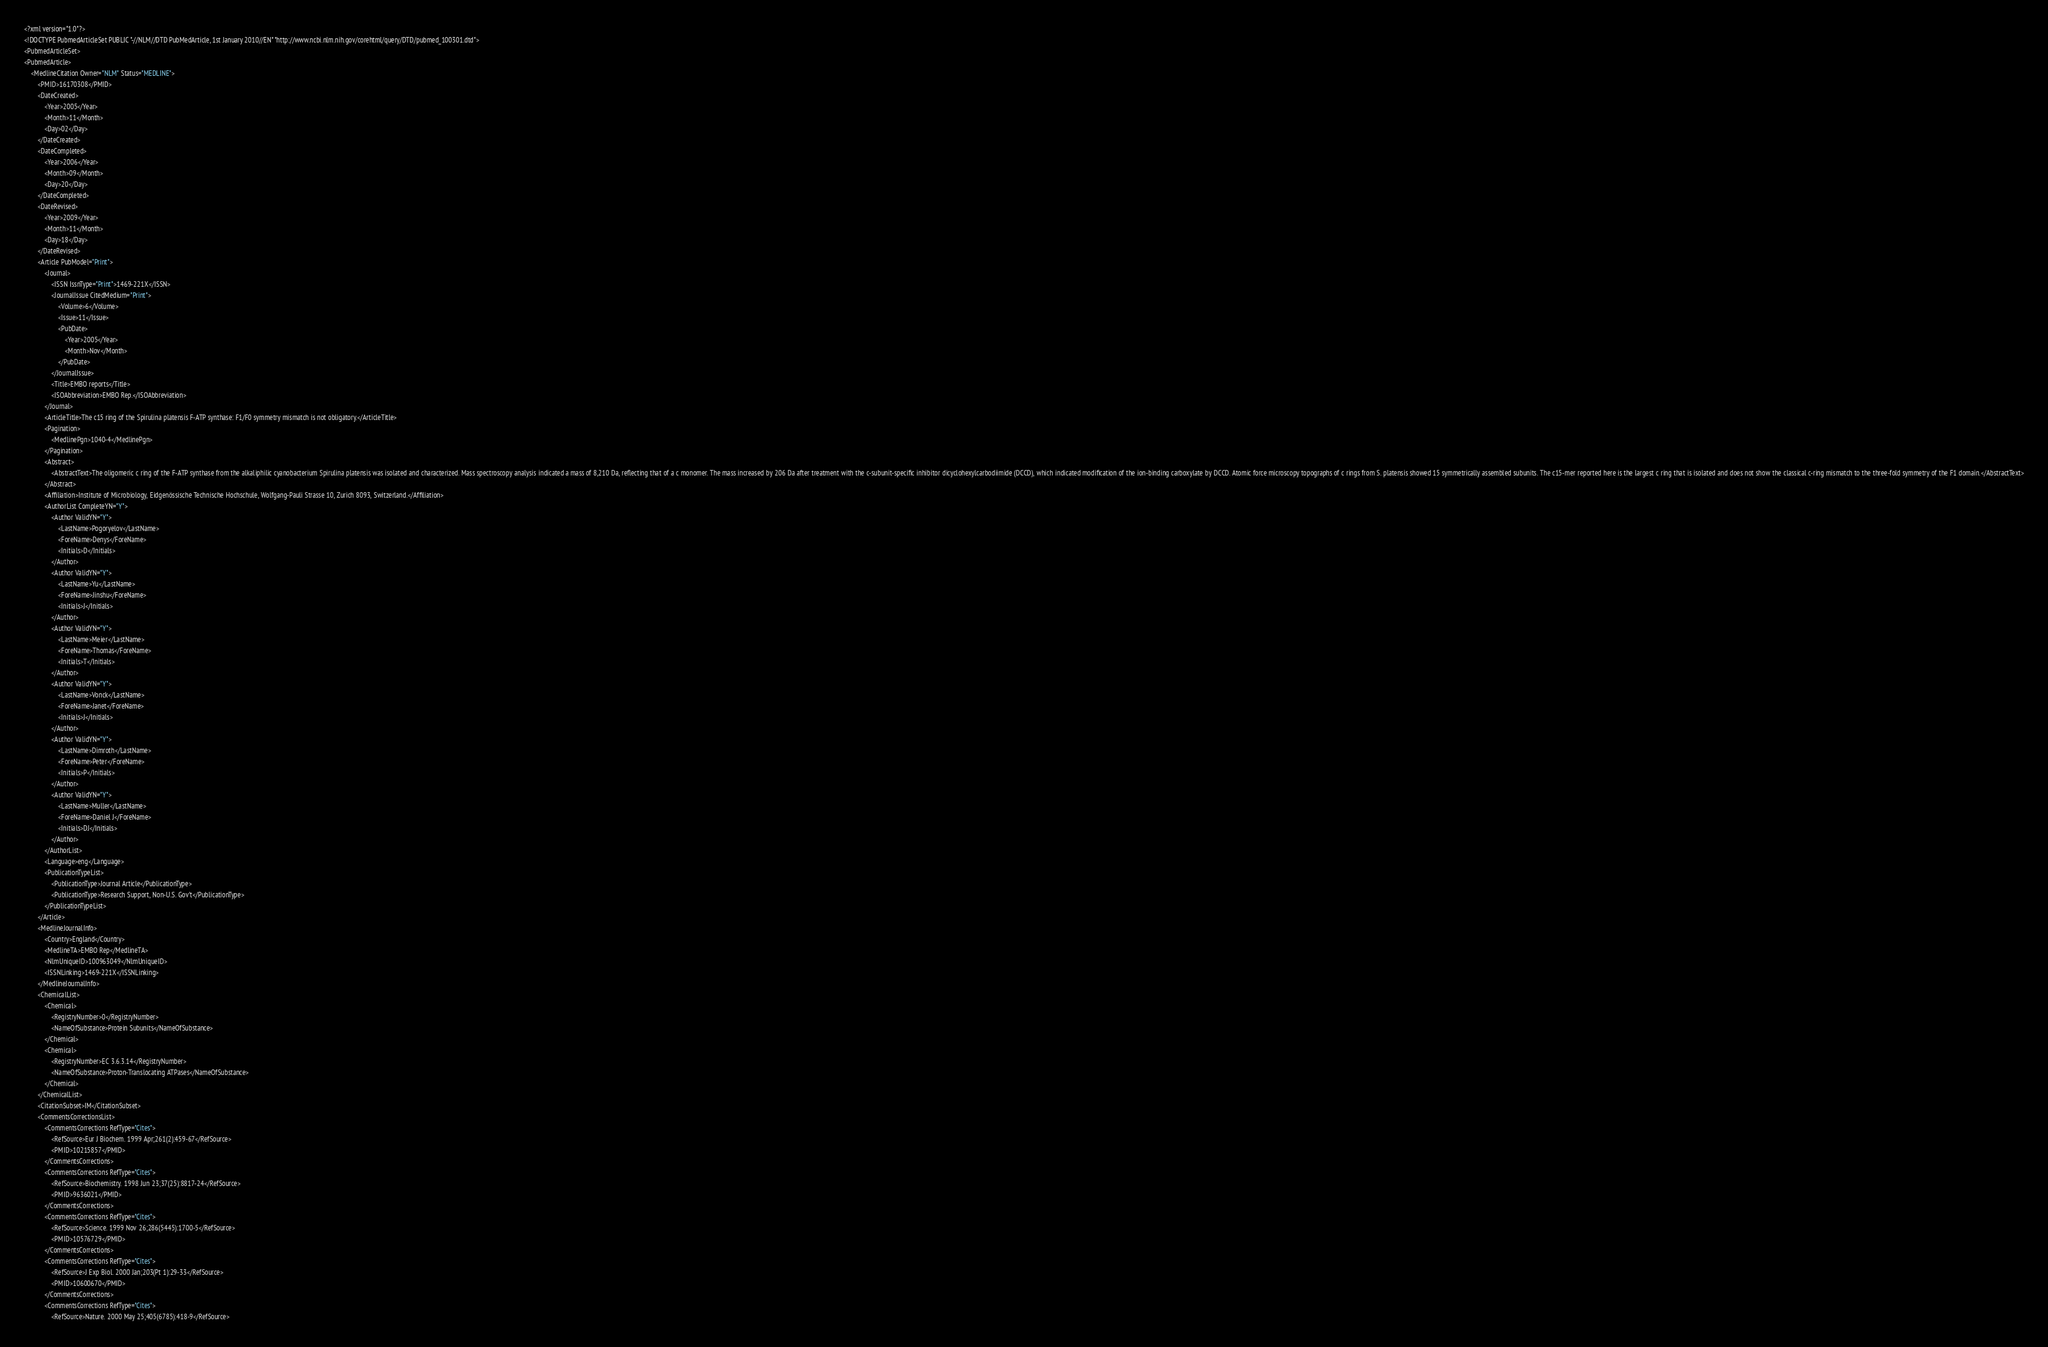<code> <loc_0><loc_0><loc_500><loc_500><_XML_><?xml version="1.0"?>
<!DOCTYPE PubmedArticleSet PUBLIC "-//NLM//DTD PubMedArticle, 1st January 2010//EN" "http://www.ncbi.nlm.nih.gov/corehtml/query/DTD/pubmed_100301.dtd">
<PubmedArticleSet>
<PubmedArticle>
    <MedlineCitation Owner="NLM" Status="MEDLINE">
        <PMID>16170308</PMID>
        <DateCreated>
            <Year>2005</Year>
            <Month>11</Month>
            <Day>02</Day>
        </DateCreated>
        <DateCompleted>
            <Year>2006</Year>
            <Month>09</Month>
            <Day>20</Day>
        </DateCompleted>
        <DateRevised>
            <Year>2009</Year>
            <Month>11</Month>
            <Day>18</Day>
        </DateRevised>
        <Article PubModel="Print">
            <Journal>
                <ISSN IssnType="Print">1469-221X</ISSN>
                <JournalIssue CitedMedium="Print">
                    <Volume>6</Volume>
                    <Issue>11</Issue>
                    <PubDate>
                        <Year>2005</Year>
                        <Month>Nov</Month>
                    </PubDate>
                </JournalIssue>
                <Title>EMBO reports</Title>
                <ISOAbbreviation>EMBO Rep.</ISOAbbreviation>
            </Journal>
            <ArticleTitle>The c15 ring of the Spirulina platensis F-ATP synthase: F1/F0 symmetry mismatch is not obligatory.</ArticleTitle>
            <Pagination>
                <MedlinePgn>1040-4</MedlinePgn>
            </Pagination>
            <Abstract>
                <AbstractText>The oligomeric c ring of the F-ATP synthase from the alkaliphilic cyanobacterium Spirulina platensis was isolated and characterized. Mass spectroscopy analysis indicated a mass of 8,210 Da, reflecting that of a c monomer. The mass increased by 206 Da after treatment with the c-subunit-specific inhibitor dicyclohexylcarbodiimide (DCCD), which indicated modification of the ion-binding carboxylate by DCCD. Atomic force microscopy topographs of c rings from S. platensis showed 15 symmetrically assembled subunits. The c15-mer reported here is the largest c ring that is isolated and does not show the classical c-ring mismatch to the three-fold symmetry of the F1 domain.</AbstractText>
            </Abstract>
            <Affiliation>Institute of Microbiology, Eidgenössische Technische Hochschule, Wolfgang-Pauli Strasse 10, Zurich 8093, Switzerland.</Affiliation>
            <AuthorList CompleteYN="Y">
                <Author ValidYN="Y">
                    <LastName>Pogoryelov</LastName>
                    <ForeName>Denys</ForeName>
                    <Initials>D</Initials>
                </Author>
                <Author ValidYN="Y">
                    <LastName>Yu</LastName>
                    <ForeName>Jinshu</ForeName>
                    <Initials>J</Initials>
                </Author>
                <Author ValidYN="Y">
                    <LastName>Meier</LastName>
                    <ForeName>Thomas</ForeName>
                    <Initials>T</Initials>
                </Author>
                <Author ValidYN="Y">
                    <LastName>Vonck</LastName>
                    <ForeName>Janet</ForeName>
                    <Initials>J</Initials>
                </Author>
                <Author ValidYN="Y">
                    <LastName>Dimroth</LastName>
                    <ForeName>Peter</ForeName>
                    <Initials>P</Initials>
                </Author>
                <Author ValidYN="Y">
                    <LastName>Muller</LastName>
                    <ForeName>Daniel J</ForeName>
                    <Initials>DJ</Initials>
                </Author>
            </AuthorList>
            <Language>eng</Language>
            <PublicationTypeList>
                <PublicationType>Journal Article</PublicationType>
                <PublicationType>Research Support, Non-U.S. Gov't</PublicationType>
            </PublicationTypeList>
        </Article>
        <MedlineJournalInfo>
            <Country>England</Country>
            <MedlineTA>EMBO Rep</MedlineTA>
            <NlmUniqueID>100963049</NlmUniqueID>
            <ISSNLinking>1469-221X</ISSNLinking>
        </MedlineJournalInfo>
        <ChemicalList>
            <Chemical>
                <RegistryNumber>0</RegistryNumber>
                <NameOfSubstance>Protein Subunits</NameOfSubstance>
            </Chemical>
            <Chemical>
                <RegistryNumber>EC 3.6.3.14</RegistryNumber>
                <NameOfSubstance>Proton-Translocating ATPases</NameOfSubstance>
            </Chemical>
        </ChemicalList>
        <CitationSubset>IM</CitationSubset>
        <CommentsCorrectionsList>
            <CommentsCorrections RefType="Cites">
                <RefSource>Eur J Biochem. 1999 Apr;261(2):459-67</RefSource>
                <PMID>10215857</PMID>
            </CommentsCorrections>
            <CommentsCorrections RefType="Cites">
                <RefSource>Biochemistry. 1998 Jun 23;37(25):8817-24</RefSource>
                <PMID>9636021</PMID>
            </CommentsCorrections>
            <CommentsCorrections RefType="Cites">
                <RefSource>Science. 1999 Nov 26;286(5445):1700-5</RefSource>
                <PMID>10576729</PMID>
            </CommentsCorrections>
            <CommentsCorrections RefType="Cites">
                <RefSource>J Exp Biol. 2000 Jan;203(Pt 1):29-33</RefSource>
                <PMID>10600670</PMID>
            </CommentsCorrections>
            <CommentsCorrections RefType="Cites">
                <RefSource>Nature. 2000 May 25;405(6785):418-9</RefSource></code> 